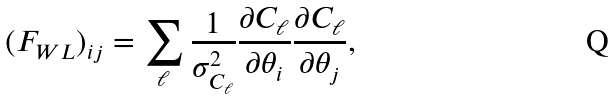<formula> <loc_0><loc_0><loc_500><loc_500>( F _ { W L } ) _ { i j } = \sum _ { \ell } \frac { 1 } { \sigma _ { C _ { \ell } } ^ { 2 } } \frac { \partial C _ { \ell } } { \partial \theta _ { i } } \frac { \partial C _ { \ell } } { \partial \theta _ { j } } ,</formula> 